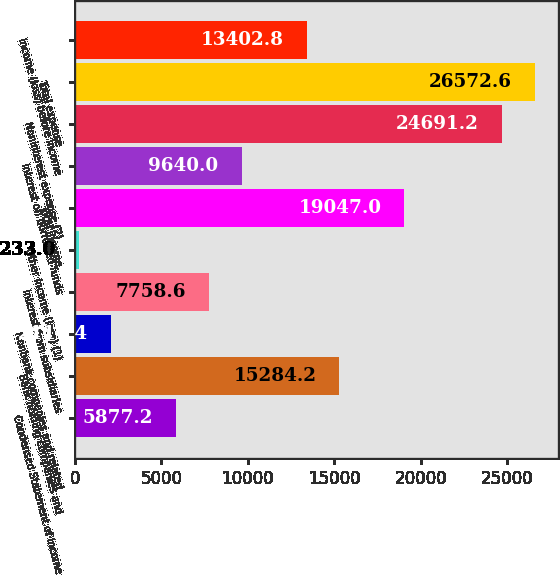<chart> <loc_0><loc_0><loc_500><loc_500><bar_chart><fcel>Condensed Statement of Income<fcel>Bank holding companies and<fcel>Nonbank companies and related<fcel>Interest from subsidiaries<fcel>Other income (loss) (1)<fcel>Total income<fcel>Interest on borrowed funds<fcel>Noninterest expense (2)<fcel>Total expense<fcel>Income (loss) before income<nl><fcel>5877.2<fcel>15284.2<fcel>2114.4<fcel>7758.6<fcel>233<fcel>19047<fcel>9640<fcel>24691.2<fcel>26572.6<fcel>13402.8<nl></chart> 